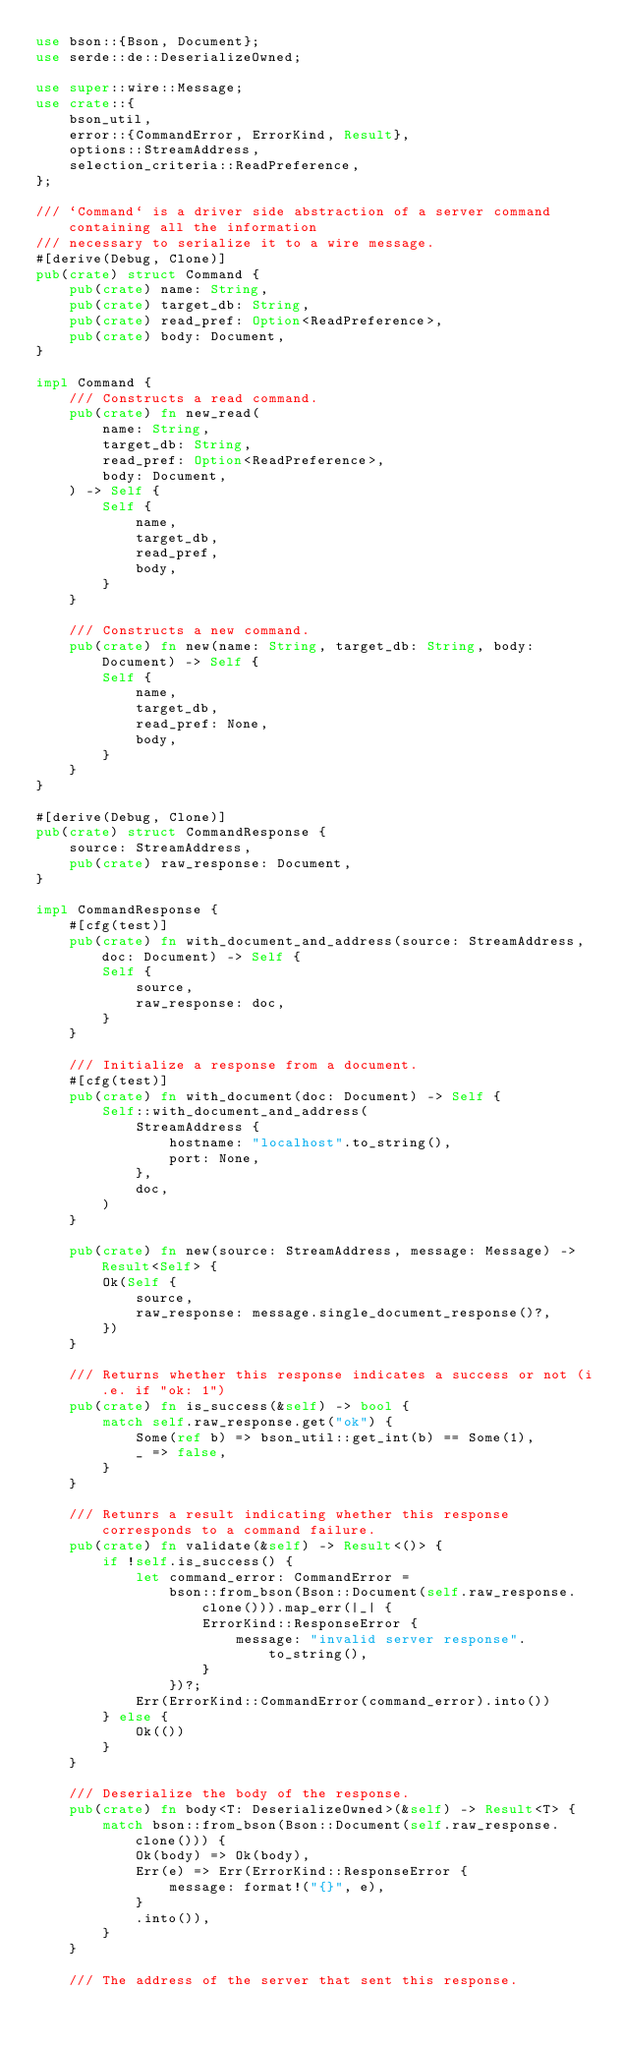<code> <loc_0><loc_0><loc_500><loc_500><_Rust_>use bson::{Bson, Document};
use serde::de::DeserializeOwned;

use super::wire::Message;
use crate::{
    bson_util,
    error::{CommandError, ErrorKind, Result},
    options::StreamAddress,
    selection_criteria::ReadPreference,
};

/// `Command` is a driver side abstraction of a server command containing all the information
/// necessary to serialize it to a wire message.
#[derive(Debug, Clone)]
pub(crate) struct Command {
    pub(crate) name: String,
    pub(crate) target_db: String,
    pub(crate) read_pref: Option<ReadPreference>,
    pub(crate) body: Document,
}

impl Command {
    /// Constructs a read command.
    pub(crate) fn new_read(
        name: String,
        target_db: String,
        read_pref: Option<ReadPreference>,
        body: Document,
    ) -> Self {
        Self {
            name,
            target_db,
            read_pref,
            body,
        }
    }

    /// Constructs a new command.
    pub(crate) fn new(name: String, target_db: String, body: Document) -> Self {
        Self {
            name,
            target_db,
            read_pref: None,
            body,
        }
    }
}

#[derive(Debug, Clone)]
pub(crate) struct CommandResponse {
    source: StreamAddress,
    pub(crate) raw_response: Document,
}

impl CommandResponse {
    #[cfg(test)]
    pub(crate) fn with_document_and_address(source: StreamAddress, doc: Document) -> Self {
        Self {
            source,
            raw_response: doc,
        }
    }

    /// Initialize a response from a document.
    #[cfg(test)]
    pub(crate) fn with_document(doc: Document) -> Self {
        Self::with_document_and_address(
            StreamAddress {
                hostname: "localhost".to_string(),
                port: None,
            },
            doc,
        )
    }

    pub(crate) fn new(source: StreamAddress, message: Message) -> Result<Self> {
        Ok(Self {
            source,
            raw_response: message.single_document_response()?,
        })
    }

    /// Returns whether this response indicates a success or not (i.e. if "ok: 1")
    pub(crate) fn is_success(&self) -> bool {
        match self.raw_response.get("ok") {
            Some(ref b) => bson_util::get_int(b) == Some(1),
            _ => false,
        }
    }

    /// Retunrs a result indicating whether this response corresponds to a command failure.
    pub(crate) fn validate(&self) -> Result<()> {
        if !self.is_success() {
            let command_error: CommandError =
                bson::from_bson(Bson::Document(self.raw_response.clone())).map_err(|_| {
                    ErrorKind::ResponseError {
                        message: "invalid server response".to_string(),
                    }
                })?;
            Err(ErrorKind::CommandError(command_error).into())
        } else {
            Ok(())
        }
    }

    /// Deserialize the body of the response.
    pub(crate) fn body<T: DeserializeOwned>(&self) -> Result<T> {
        match bson::from_bson(Bson::Document(self.raw_response.clone())) {
            Ok(body) => Ok(body),
            Err(e) => Err(ErrorKind::ResponseError {
                message: format!("{}", e),
            }
            .into()),
        }
    }

    /// The address of the server that sent this response.</code> 